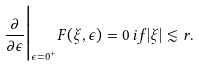<formula> <loc_0><loc_0><loc_500><loc_500>\frac { \partial } { \partial \epsilon } \Big | _ { \epsilon = 0 ^ { + } } F ( \xi , \epsilon ) = 0 \, i f | \xi | \lesssim r .</formula> 